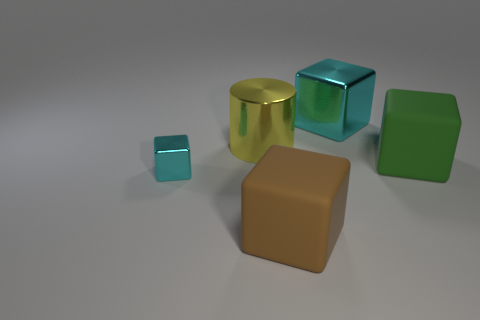Which shapes present in the image do not follow the color matching pattern? The golden cylinder and the green parallelogram do not follow the color matching pattern, as they are unique in color and lack a corresponding object with a matching hue. 